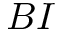<formula> <loc_0><loc_0><loc_500><loc_500>B I</formula> 